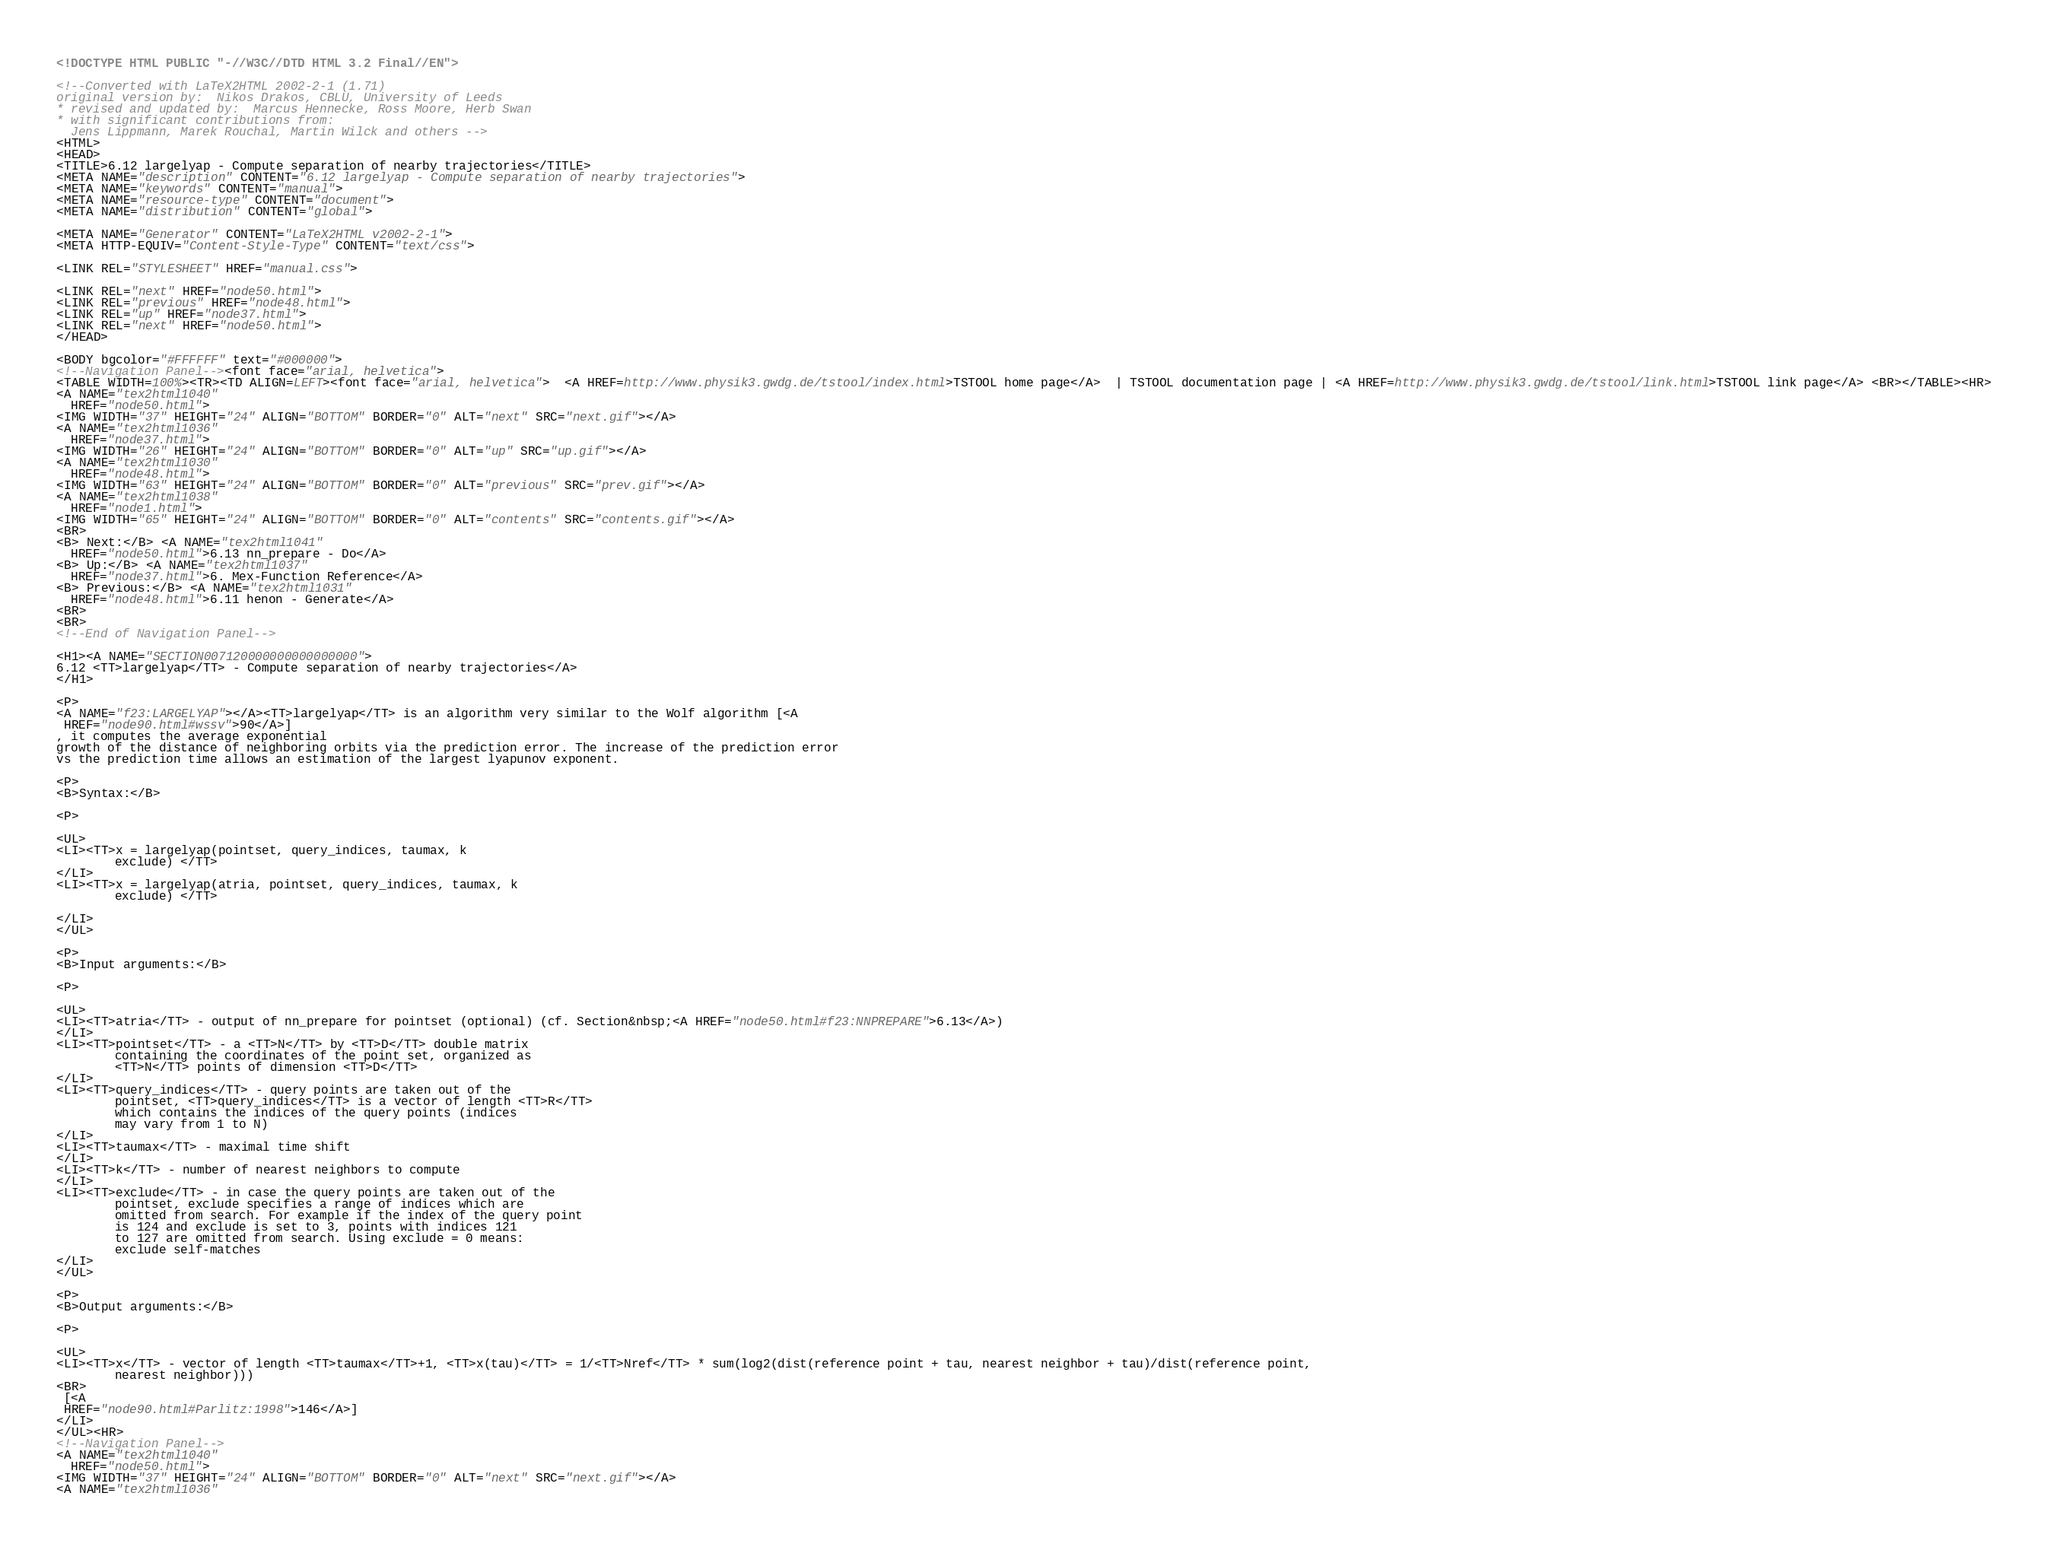<code> <loc_0><loc_0><loc_500><loc_500><_HTML_><!DOCTYPE HTML PUBLIC "-//W3C//DTD HTML 3.2 Final//EN">

<!--Converted with LaTeX2HTML 2002-2-1 (1.71)
original version by:  Nikos Drakos, CBLU, University of Leeds
* revised and updated by:  Marcus Hennecke, Ross Moore, Herb Swan
* with significant contributions from:
  Jens Lippmann, Marek Rouchal, Martin Wilck and others -->
<HTML>
<HEAD>
<TITLE>6.12 largelyap - Compute separation of nearby trajectories</TITLE>
<META NAME="description" CONTENT="6.12 largelyap - Compute separation of nearby trajectories">
<META NAME="keywords" CONTENT="manual">
<META NAME="resource-type" CONTENT="document">
<META NAME="distribution" CONTENT="global">

<META NAME="Generator" CONTENT="LaTeX2HTML v2002-2-1">
<META HTTP-EQUIV="Content-Style-Type" CONTENT="text/css">

<LINK REL="STYLESHEET" HREF="manual.css">

<LINK REL="next" HREF="node50.html">
<LINK REL="previous" HREF="node48.html">
<LINK REL="up" HREF="node37.html">
<LINK REL="next" HREF="node50.html">
</HEAD>

<BODY bgcolor="#FFFFFF" text="#000000">
<!--Navigation Panel--><font face="arial, helvetica">
<TABLE WIDTH=100%><TR><TD ALIGN=LEFT><font face="arial, helvetica">  <A HREF=http://www.physik3.gwdg.de/tstool/index.html>TSTOOL home page</A>  | TSTOOL documentation page | <A HREF=http://www.physik3.gwdg.de/tstool/link.html>TSTOOL link page</A> <BR></TABLE><HR>
<A NAME="tex2html1040"
  HREF="node50.html">
<IMG WIDTH="37" HEIGHT="24" ALIGN="BOTTOM" BORDER="0" ALT="next" SRC="next.gif"></A> 
<A NAME="tex2html1036"
  HREF="node37.html">
<IMG WIDTH="26" HEIGHT="24" ALIGN="BOTTOM" BORDER="0" ALT="up" SRC="up.gif"></A> 
<A NAME="tex2html1030"
  HREF="node48.html">
<IMG WIDTH="63" HEIGHT="24" ALIGN="BOTTOM" BORDER="0" ALT="previous" SRC="prev.gif"></A> 
<A NAME="tex2html1038"
  HREF="node1.html">
<IMG WIDTH="65" HEIGHT="24" ALIGN="BOTTOM" BORDER="0" ALT="contents" SRC="contents.gif"></A>  
<BR>
<B> Next:</B> <A NAME="tex2html1041"
  HREF="node50.html">6.13 nn_prepare - Do</A>
<B> Up:</B> <A NAME="tex2html1037"
  HREF="node37.html">6. Mex-Function Reference</A>
<B> Previous:</B> <A NAME="tex2html1031"
  HREF="node48.html">6.11 henon - Generate</A>
<BR>
<BR>
<!--End of Navigation Panel-->

<H1><A NAME="SECTION007120000000000000000">
6.12 <TT>largelyap</TT> - Compute separation of nearby trajectories</A>
</H1>

<P>
<A NAME="f23:LARGELYAP"></A><TT>largelyap</TT> is an algorithm very similar to the Wolf algorithm [<A
 HREF="node90.html#wssv">90</A>]
, it computes the average exponential 
growth of the distance of neighboring orbits via the prediction error. The increase of the prediction error
vs the prediction time allows an estimation of the largest lyapunov exponent.

<P>
<B>Syntax:</B>

<P>

<UL>
<LI><TT>x = largelyap(pointset, query_indices, taumax, k
        exclude) </TT>
</LI>
<LI><TT>x = largelyap(atria, pointset, query_indices, taumax, k
        exclude) </TT>
    
</LI>
</UL>

<P>
<B>Input arguments:</B>

<P>

<UL>
<LI><TT>atria</TT> - output of nn_prepare for pointset (optional) (cf. Section&nbsp;<A HREF="node50.html#f23:NNPREPARE">6.13</A>)
</LI>
<LI><TT>pointset</TT> - a <TT>N</TT> by <TT>D</TT> double matrix
        containing the coordinates of the point set, organized as
        <TT>N</TT> points of dimension <TT>D</TT> 
</LI>
<LI><TT>query_indices</TT> - query points are taken out of the
        pointset, <TT>query_indices</TT> is a vector of length <TT>R</TT>
        which contains the indices of the query points (indices
        may vary from 1 to N) 
</LI>
<LI><TT>taumax</TT> - maximal time shift         
</LI>
<LI><TT>k</TT> - number of nearest neighbors to compute  
</LI>
<LI><TT>exclude</TT> - in case the query points are taken out of the
        pointset, exclude specifies a range of indices which are
        omitted from search. For example if the index of the query point
        is 124 and exclude is set to 3, points with indices 121
        to 127 are omitted from search. Using exclude = 0 means:
        exclude self-matches 
</LI>
</UL>

<P>
<B>Output arguments:</B>

<P>

<UL>
<LI><TT>x</TT> - vector of length <TT>taumax</TT>+1, <TT>x(tau)</TT> = 1/<TT>Nref</TT> * sum(log2(dist(reference point + tau, nearest neighbor + tau)/dist(reference point, 
        nearest neighbor)))
<BR>
 [<A
 HREF="node90.html#Parlitz:1998">146</A>]
</LI>
</UL><HR>
<!--Navigation Panel-->
<A NAME="tex2html1040"
  HREF="node50.html">
<IMG WIDTH="37" HEIGHT="24" ALIGN="BOTTOM" BORDER="0" ALT="next" SRC="next.gif"></A> 
<A NAME="tex2html1036"</code> 